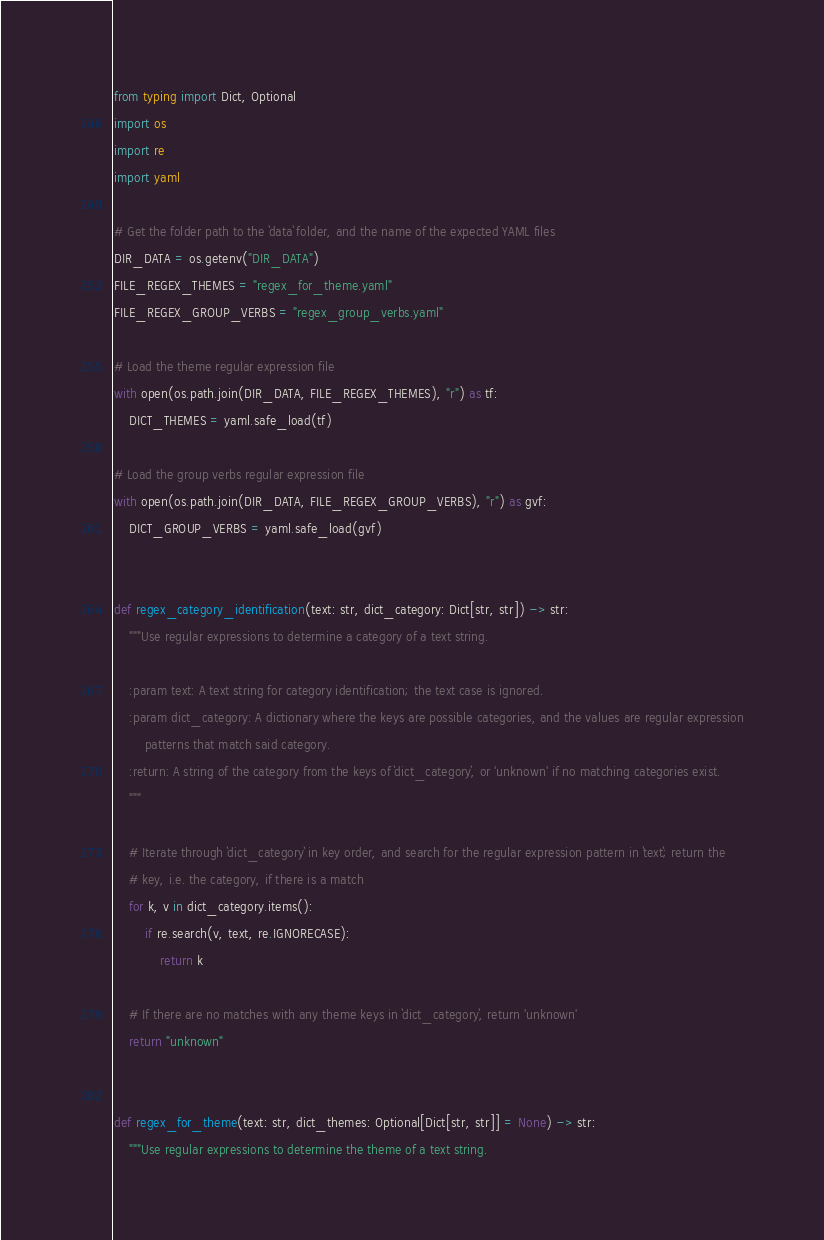<code> <loc_0><loc_0><loc_500><loc_500><_Python_>from typing import Dict, Optional
import os
import re
import yaml

# Get the folder path to the `data` folder, and the name of the expected YAML files
DIR_DATA = os.getenv("DIR_DATA")
FILE_REGEX_THEMES = "regex_for_theme.yaml"
FILE_REGEX_GROUP_VERBS = "regex_group_verbs.yaml"

# Load the theme regular expression file
with open(os.path.join(DIR_DATA, FILE_REGEX_THEMES), "r") as tf:
    DICT_THEMES = yaml.safe_load(tf)

# Load the group verbs regular expression file
with open(os.path.join(DIR_DATA, FILE_REGEX_GROUP_VERBS), "r") as gvf:
    DICT_GROUP_VERBS = yaml.safe_load(gvf)


def regex_category_identification(text: str, dict_category: Dict[str, str]) -> str:
    """Use regular expressions to determine a category of a text string.

    :param text: A text string for category identification; the text case is ignored.
    :param dict_category: A dictionary where the keys are possible categories, and the values are regular expression
        patterns that match said category.
    :return: A string of the category from the keys of `dict_category`, or 'unknown' if no matching categories exist.
    """

    # Iterate through `dict_category` in key order, and search for the regular expression pattern in `text`; return the
    # key, i.e. the category, if there is a match
    for k, v in dict_category.items():
        if re.search(v, text, re.IGNORECASE):
            return k

    # If there are no matches with any theme keys in `dict_category`, return 'unknown'
    return "unknown"


def regex_for_theme(text: str, dict_themes: Optional[Dict[str, str]] = None) -> str:
    """Use regular expressions to determine the theme of a text string.
</code> 